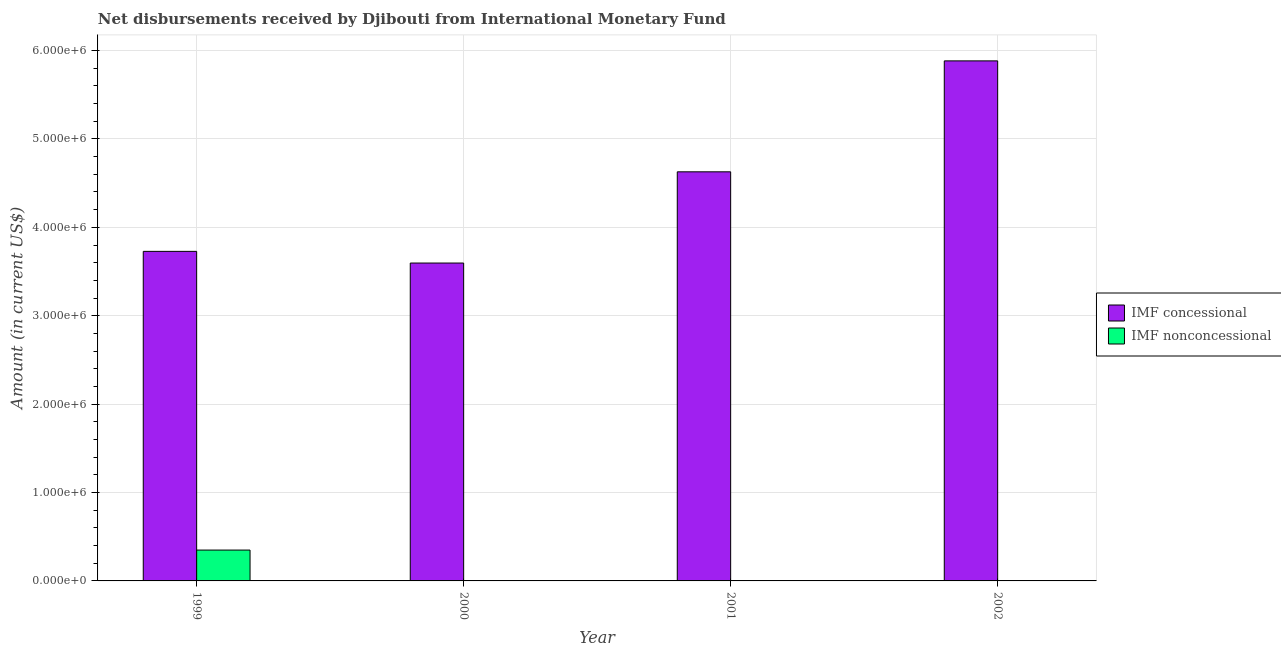Are the number of bars on each tick of the X-axis equal?
Make the answer very short. No. How many bars are there on the 1st tick from the left?
Your response must be concise. 2. What is the net non concessional disbursements from imf in 2002?
Keep it short and to the point. 0. Across all years, what is the maximum net non concessional disbursements from imf?
Ensure brevity in your answer.  3.49e+05. In which year was the net concessional disbursements from imf maximum?
Give a very brief answer. 2002. What is the total net non concessional disbursements from imf in the graph?
Your answer should be very brief. 3.49e+05. What is the difference between the net concessional disbursements from imf in 2000 and that in 2002?
Keep it short and to the point. -2.29e+06. What is the difference between the net non concessional disbursements from imf in 2002 and the net concessional disbursements from imf in 1999?
Keep it short and to the point. -3.49e+05. What is the average net concessional disbursements from imf per year?
Your answer should be compact. 4.46e+06. In the year 1999, what is the difference between the net non concessional disbursements from imf and net concessional disbursements from imf?
Make the answer very short. 0. What is the ratio of the net concessional disbursements from imf in 2000 to that in 2002?
Keep it short and to the point. 0.61. Is the net concessional disbursements from imf in 2000 less than that in 2002?
Provide a succinct answer. Yes. What is the difference between the highest and the second highest net concessional disbursements from imf?
Your answer should be compact. 1.26e+06. What is the difference between the highest and the lowest net non concessional disbursements from imf?
Offer a terse response. 3.49e+05. In how many years, is the net non concessional disbursements from imf greater than the average net non concessional disbursements from imf taken over all years?
Offer a terse response. 1. Is the sum of the net concessional disbursements from imf in 2000 and 2001 greater than the maximum net non concessional disbursements from imf across all years?
Your answer should be compact. Yes. Are all the bars in the graph horizontal?
Provide a succinct answer. No. What is the difference between two consecutive major ticks on the Y-axis?
Your answer should be compact. 1.00e+06. Are the values on the major ticks of Y-axis written in scientific E-notation?
Ensure brevity in your answer.  Yes. Where does the legend appear in the graph?
Make the answer very short. Center right. What is the title of the graph?
Offer a terse response. Net disbursements received by Djibouti from International Monetary Fund. Does "Exports" appear as one of the legend labels in the graph?
Offer a very short reply. No. What is the Amount (in current US$) of IMF concessional in 1999?
Give a very brief answer. 3.73e+06. What is the Amount (in current US$) in IMF nonconcessional in 1999?
Offer a terse response. 3.49e+05. What is the Amount (in current US$) of IMF concessional in 2000?
Make the answer very short. 3.60e+06. What is the Amount (in current US$) in IMF nonconcessional in 2000?
Provide a succinct answer. 0. What is the Amount (in current US$) in IMF concessional in 2001?
Offer a terse response. 4.63e+06. What is the Amount (in current US$) of IMF concessional in 2002?
Offer a terse response. 5.88e+06. What is the Amount (in current US$) of IMF nonconcessional in 2002?
Keep it short and to the point. 0. Across all years, what is the maximum Amount (in current US$) of IMF concessional?
Provide a succinct answer. 5.88e+06. Across all years, what is the maximum Amount (in current US$) in IMF nonconcessional?
Give a very brief answer. 3.49e+05. Across all years, what is the minimum Amount (in current US$) in IMF concessional?
Your response must be concise. 3.60e+06. What is the total Amount (in current US$) of IMF concessional in the graph?
Give a very brief answer. 1.78e+07. What is the total Amount (in current US$) of IMF nonconcessional in the graph?
Make the answer very short. 3.49e+05. What is the difference between the Amount (in current US$) of IMF concessional in 1999 and that in 2000?
Your response must be concise. 1.32e+05. What is the difference between the Amount (in current US$) in IMF concessional in 1999 and that in 2001?
Ensure brevity in your answer.  -9.00e+05. What is the difference between the Amount (in current US$) of IMF concessional in 1999 and that in 2002?
Keep it short and to the point. -2.16e+06. What is the difference between the Amount (in current US$) of IMF concessional in 2000 and that in 2001?
Your answer should be compact. -1.03e+06. What is the difference between the Amount (in current US$) of IMF concessional in 2000 and that in 2002?
Your response must be concise. -2.29e+06. What is the difference between the Amount (in current US$) of IMF concessional in 2001 and that in 2002?
Offer a very short reply. -1.26e+06. What is the average Amount (in current US$) of IMF concessional per year?
Offer a terse response. 4.46e+06. What is the average Amount (in current US$) of IMF nonconcessional per year?
Make the answer very short. 8.72e+04. In the year 1999, what is the difference between the Amount (in current US$) of IMF concessional and Amount (in current US$) of IMF nonconcessional?
Make the answer very short. 3.38e+06. What is the ratio of the Amount (in current US$) in IMF concessional in 1999 to that in 2000?
Your answer should be very brief. 1.04. What is the ratio of the Amount (in current US$) of IMF concessional in 1999 to that in 2001?
Your response must be concise. 0.81. What is the ratio of the Amount (in current US$) of IMF concessional in 1999 to that in 2002?
Give a very brief answer. 0.63. What is the ratio of the Amount (in current US$) in IMF concessional in 2000 to that in 2001?
Provide a succinct answer. 0.78. What is the ratio of the Amount (in current US$) in IMF concessional in 2000 to that in 2002?
Provide a succinct answer. 0.61. What is the ratio of the Amount (in current US$) of IMF concessional in 2001 to that in 2002?
Offer a very short reply. 0.79. What is the difference between the highest and the second highest Amount (in current US$) of IMF concessional?
Your response must be concise. 1.26e+06. What is the difference between the highest and the lowest Amount (in current US$) in IMF concessional?
Offer a very short reply. 2.29e+06. What is the difference between the highest and the lowest Amount (in current US$) of IMF nonconcessional?
Offer a very short reply. 3.49e+05. 